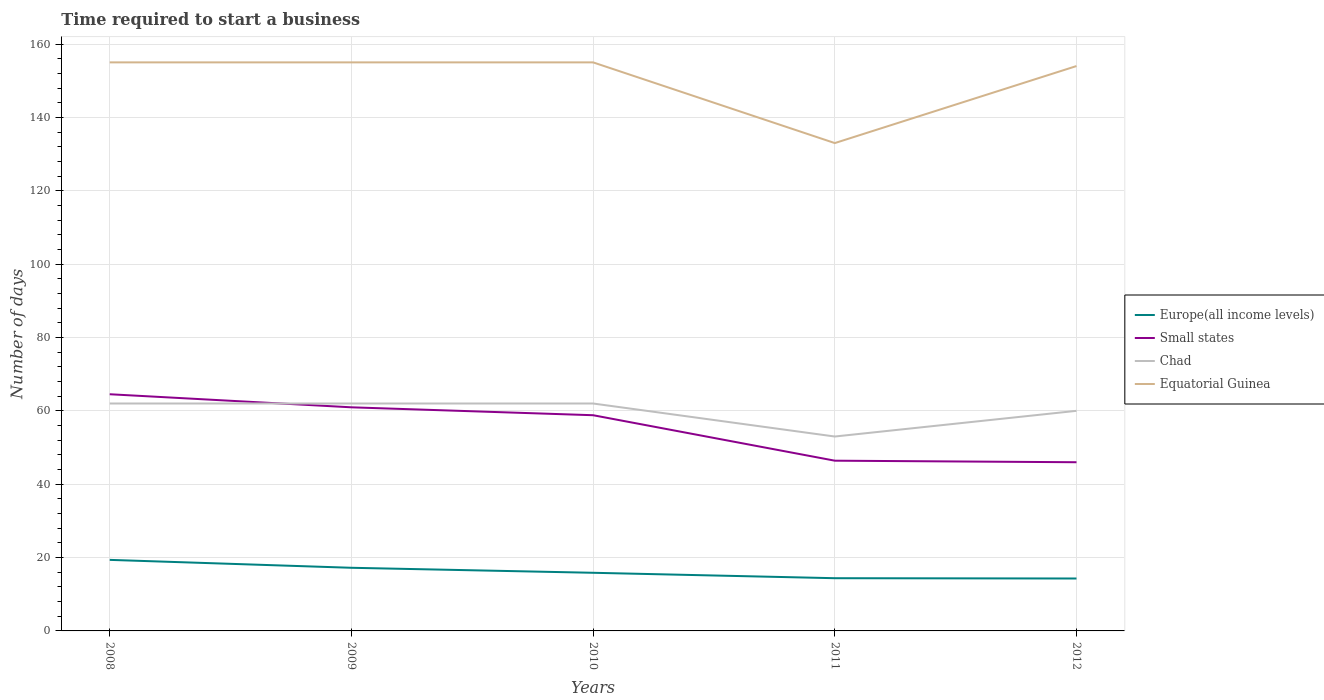Is the number of lines equal to the number of legend labels?
Provide a short and direct response. Yes. Across all years, what is the maximum number of days required to start a business in Chad?
Make the answer very short. 53. What is the total number of days required to start a business in Europe(all income levels) in the graph?
Your answer should be compact. 2.92. What is the difference between the highest and the second highest number of days required to start a business in Chad?
Your answer should be compact. 9. What is the difference between the highest and the lowest number of days required to start a business in Equatorial Guinea?
Provide a short and direct response. 4. Is the number of days required to start a business in Chad strictly greater than the number of days required to start a business in Europe(all income levels) over the years?
Your answer should be compact. No. What is the difference between two consecutive major ticks on the Y-axis?
Ensure brevity in your answer.  20. What is the title of the graph?
Provide a short and direct response. Time required to start a business. What is the label or title of the X-axis?
Give a very brief answer. Years. What is the label or title of the Y-axis?
Your answer should be compact. Number of days. What is the Number of days in Europe(all income levels) in 2008?
Ensure brevity in your answer.  19.37. What is the Number of days of Small states in 2008?
Provide a succinct answer. 64.53. What is the Number of days in Equatorial Guinea in 2008?
Offer a terse response. 155. What is the Number of days of Europe(all income levels) in 2009?
Your response must be concise. 17.21. What is the Number of days in Small states in 2009?
Your response must be concise. 60.96. What is the Number of days in Equatorial Guinea in 2009?
Provide a short and direct response. 155. What is the Number of days of Europe(all income levels) in 2010?
Offer a very short reply. 15.85. What is the Number of days in Small states in 2010?
Make the answer very short. 58.81. What is the Number of days of Equatorial Guinea in 2010?
Give a very brief answer. 155. What is the Number of days in Europe(all income levels) in 2011?
Give a very brief answer. 14.37. What is the Number of days of Small states in 2011?
Your answer should be very brief. 46.41. What is the Number of days in Chad in 2011?
Keep it short and to the point. 53. What is the Number of days in Equatorial Guinea in 2011?
Offer a very short reply. 133. What is the Number of days of Europe(all income levels) in 2012?
Your answer should be compact. 14.29. What is the Number of days of Small states in 2012?
Provide a succinct answer. 45.99. What is the Number of days of Equatorial Guinea in 2012?
Your answer should be compact. 154. Across all years, what is the maximum Number of days of Europe(all income levels)?
Your response must be concise. 19.37. Across all years, what is the maximum Number of days of Small states?
Keep it short and to the point. 64.53. Across all years, what is the maximum Number of days in Equatorial Guinea?
Provide a succinct answer. 155. Across all years, what is the minimum Number of days in Europe(all income levels)?
Ensure brevity in your answer.  14.29. Across all years, what is the minimum Number of days of Small states?
Offer a terse response. 45.99. Across all years, what is the minimum Number of days in Chad?
Make the answer very short. 53. Across all years, what is the minimum Number of days in Equatorial Guinea?
Offer a very short reply. 133. What is the total Number of days in Europe(all income levels) in the graph?
Give a very brief answer. 81.1. What is the total Number of days of Small states in the graph?
Ensure brevity in your answer.  276.69. What is the total Number of days in Chad in the graph?
Provide a short and direct response. 299. What is the total Number of days of Equatorial Guinea in the graph?
Your answer should be compact. 752. What is the difference between the Number of days of Europe(all income levels) in 2008 and that in 2009?
Your answer should be compact. 2.16. What is the difference between the Number of days in Small states in 2008 and that in 2009?
Ensure brevity in your answer.  3.56. What is the difference between the Number of days in Chad in 2008 and that in 2009?
Offer a terse response. 0. What is the difference between the Number of days in Europe(all income levels) in 2008 and that in 2010?
Your answer should be very brief. 3.52. What is the difference between the Number of days in Small states in 2008 and that in 2010?
Offer a very short reply. 5.72. What is the difference between the Number of days in Equatorial Guinea in 2008 and that in 2010?
Give a very brief answer. 0. What is the difference between the Number of days in Europe(all income levels) in 2008 and that in 2011?
Your answer should be compact. 5. What is the difference between the Number of days in Small states in 2008 and that in 2011?
Give a very brief answer. 18.11. What is the difference between the Number of days in Chad in 2008 and that in 2011?
Offer a terse response. 9. What is the difference between the Number of days of Europe(all income levels) in 2008 and that in 2012?
Keep it short and to the point. 5.08. What is the difference between the Number of days in Small states in 2008 and that in 2012?
Give a very brief answer. 18.54. What is the difference between the Number of days in Chad in 2008 and that in 2012?
Make the answer very short. 2. What is the difference between the Number of days in Europe(all income levels) in 2009 and that in 2010?
Give a very brief answer. 1.36. What is the difference between the Number of days of Small states in 2009 and that in 2010?
Make the answer very short. 2.15. What is the difference between the Number of days of Chad in 2009 and that in 2010?
Keep it short and to the point. 0. What is the difference between the Number of days in Equatorial Guinea in 2009 and that in 2010?
Provide a succinct answer. 0. What is the difference between the Number of days in Europe(all income levels) in 2009 and that in 2011?
Offer a terse response. 2.84. What is the difference between the Number of days in Small states in 2009 and that in 2011?
Make the answer very short. 14.55. What is the difference between the Number of days of Equatorial Guinea in 2009 and that in 2011?
Offer a very short reply. 22. What is the difference between the Number of days in Europe(all income levels) in 2009 and that in 2012?
Offer a very short reply. 2.92. What is the difference between the Number of days in Small states in 2009 and that in 2012?
Offer a terse response. 14.97. What is the difference between the Number of days of Chad in 2009 and that in 2012?
Provide a short and direct response. 2. What is the difference between the Number of days of Europe(all income levels) in 2010 and that in 2011?
Provide a succinct answer. 1.48. What is the difference between the Number of days of Small states in 2010 and that in 2011?
Your response must be concise. 12.4. What is the difference between the Number of days in Chad in 2010 and that in 2011?
Your answer should be very brief. 9. What is the difference between the Number of days in Equatorial Guinea in 2010 and that in 2011?
Provide a short and direct response. 22. What is the difference between the Number of days in Europe(all income levels) in 2010 and that in 2012?
Your answer should be very brief. 1.56. What is the difference between the Number of days of Small states in 2010 and that in 2012?
Your response must be concise. 12.82. What is the difference between the Number of days in Equatorial Guinea in 2010 and that in 2012?
Make the answer very short. 1. What is the difference between the Number of days in Europe(all income levels) in 2011 and that in 2012?
Provide a short and direct response. 0.08. What is the difference between the Number of days of Small states in 2011 and that in 2012?
Offer a terse response. 0.42. What is the difference between the Number of days in Europe(all income levels) in 2008 and the Number of days in Small states in 2009?
Your answer should be very brief. -41.59. What is the difference between the Number of days in Europe(all income levels) in 2008 and the Number of days in Chad in 2009?
Provide a succinct answer. -42.63. What is the difference between the Number of days of Europe(all income levels) in 2008 and the Number of days of Equatorial Guinea in 2009?
Give a very brief answer. -135.63. What is the difference between the Number of days in Small states in 2008 and the Number of days in Chad in 2009?
Your answer should be very brief. 2.53. What is the difference between the Number of days in Small states in 2008 and the Number of days in Equatorial Guinea in 2009?
Your answer should be very brief. -90.47. What is the difference between the Number of days in Chad in 2008 and the Number of days in Equatorial Guinea in 2009?
Offer a terse response. -93. What is the difference between the Number of days of Europe(all income levels) in 2008 and the Number of days of Small states in 2010?
Give a very brief answer. -39.44. What is the difference between the Number of days in Europe(all income levels) in 2008 and the Number of days in Chad in 2010?
Your answer should be very brief. -42.63. What is the difference between the Number of days of Europe(all income levels) in 2008 and the Number of days of Equatorial Guinea in 2010?
Your answer should be very brief. -135.63. What is the difference between the Number of days of Small states in 2008 and the Number of days of Chad in 2010?
Ensure brevity in your answer.  2.53. What is the difference between the Number of days of Small states in 2008 and the Number of days of Equatorial Guinea in 2010?
Your answer should be very brief. -90.47. What is the difference between the Number of days in Chad in 2008 and the Number of days in Equatorial Guinea in 2010?
Offer a very short reply. -93. What is the difference between the Number of days of Europe(all income levels) in 2008 and the Number of days of Small states in 2011?
Ensure brevity in your answer.  -27.04. What is the difference between the Number of days in Europe(all income levels) in 2008 and the Number of days in Chad in 2011?
Your answer should be compact. -33.63. What is the difference between the Number of days of Europe(all income levels) in 2008 and the Number of days of Equatorial Guinea in 2011?
Your answer should be very brief. -113.63. What is the difference between the Number of days of Small states in 2008 and the Number of days of Chad in 2011?
Ensure brevity in your answer.  11.53. What is the difference between the Number of days in Small states in 2008 and the Number of days in Equatorial Guinea in 2011?
Give a very brief answer. -68.47. What is the difference between the Number of days in Chad in 2008 and the Number of days in Equatorial Guinea in 2011?
Make the answer very short. -71. What is the difference between the Number of days in Europe(all income levels) in 2008 and the Number of days in Small states in 2012?
Make the answer very short. -26.62. What is the difference between the Number of days of Europe(all income levels) in 2008 and the Number of days of Chad in 2012?
Offer a terse response. -40.63. What is the difference between the Number of days of Europe(all income levels) in 2008 and the Number of days of Equatorial Guinea in 2012?
Make the answer very short. -134.63. What is the difference between the Number of days in Small states in 2008 and the Number of days in Chad in 2012?
Your response must be concise. 4.53. What is the difference between the Number of days in Small states in 2008 and the Number of days in Equatorial Guinea in 2012?
Provide a short and direct response. -89.47. What is the difference between the Number of days of Chad in 2008 and the Number of days of Equatorial Guinea in 2012?
Give a very brief answer. -92. What is the difference between the Number of days in Europe(all income levels) in 2009 and the Number of days in Small states in 2010?
Provide a succinct answer. -41.59. What is the difference between the Number of days in Europe(all income levels) in 2009 and the Number of days in Chad in 2010?
Keep it short and to the point. -44.79. What is the difference between the Number of days in Europe(all income levels) in 2009 and the Number of days in Equatorial Guinea in 2010?
Keep it short and to the point. -137.79. What is the difference between the Number of days of Small states in 2009 and the Number of days of Chad in 2010?
Give a very brief answer. -1.04. What is the difference between the Number of days of Small states in 2009 and the Number of days of Equatorial Guinea in 2010?
Provide a succinct answer. -94.04. What is the difference between the Number of days in Chad in 2009 and the Number of days in Equatorial Guinea in 2010?
Provide a succinct answer. -93. What is the difference between the Number of days of Europe(all income levels) in 2009 and the Number of days of Small states in 2011?
Provide a short and direct response. -29.2. What is the difference between the Number of days of Europe(all income levels) in 2009 and the Number of days of Chad in 2011?
Offer a very short reply. -35.79. What is the difference between the Number of days of Europe(all income levels) in 2009 and the Number of days of Equatorial Guinea in 2011?
Provide a succinct answer. -115.79. What is the difference between the Number of days in Small states in 2009 and the Number of days in Chad in 2011?
Ensure brevity in your answer.  7.96. What is the difference between the Number of days in Small states in 2009 and the Number of days in Equatorial Guinea in 2011?
Provide a succinct answer. -72.04. What is the difference between the Number of days in Chad in 2009 and the Number of days in Equatorial Guinea in 2011?
Your answer should be compact. -71. What is the difference between the Number of days in Europe(all income levels) in 2009 and the Number of days in Small states in 2012?
Your answer should be very brief. -28.77. What is the difference between the Number of days of Europe(all income levels) in 2009 and the Number of days of Chad in 2012?
Make the answer very short. -42.79. What is the difference between the Number of days in Europe(all income levels) in 2009 and the Number of days in Equatorial Guinea in 2012?
Offer a very short reply. -136.79. What is the difference between the Number of days in Small states in 2009 and the Number of days in Chad in 2012?
Keep it short and to the point. 0.96. What is the difference between the Number of days in Small states in 2009 and the Number of days in Equatorial Guinea in 2012?
Offer a very short reply. -93.04. What is the difference between the Number of days in Chad in 2009 and the Number of days in Equatorial Guinea in 2012?
Offer a terse response. -92. What is the difference between the Number of days of Europe(all income levels) in 2010 and the Number of days of Small states in 2011?
Ensure brevity in your answer.  -30.56. What is the difference between the Number of days in Europe(all income levels) in 2010 and the Number of days in Chad in 2011?
Ensure brevity in your answer.  -37.15. What is the difference between the Number of days in Europe(all income levels) in 2010 and the Number of days in Equatorial Guinea in 2011?
Your response must be concise. -117.15. What is the difference between the Number of days in Small states in 2010 and the Number of days in Chad in 2011?
Provide a succinct answer. 5.81. What is the difference between the Number of days of Small states in 2010 and the Number of days of Equatorial Guinea in 2011?
Provide a short and direct response. -74.19. What is the difference between the Number of days of Chad in 2010 and the Number of days of Equatorial Guinea in 2011?
Your response must be concise. -71. What is the difference between the Number of days in Europe(all income levels) in 2010 and the Number of days in Small states in 2012?
Offer a terse response. -30.14. What is the difference between the Number of days of Europe(all income levels) in 2010 and the Number of days of Chad in 2012?
Make the answer very short. -44.15. What is the difference between the Number of days in Europe(all income levels) in 2010 and the Number of days in Equatorial Guinea in 2012?
Ensure brevity in your answer.  -138.15. What is the difference between the Number of days of Small states in 2010 and the Number of days of Chad in 2012?
Give a very brief answer. -1.19. What is the difference between the Number of days of Small states in 2010 and the Number of days of Equatorial Guinea in 2012?
Your answer should be very brief. -95.19. What is the difference between the Number of days in Chad in 2010 and the Number of days in Equatorial Guinea in 2012?
Provide a succinct answer. -92. What is the difference between the Number of days in Europe(all income levels) in 2011 and the Number of days in Small states in 2012?
Ensure brevity in your answer.  -31.62. What is the difference between the Number of days of Europe(all income levels) in 2011 and the Number of days of Chad in 2012?
Provide a short and direct response. -45.63. What is the difference between the Number of days of Europe(all income levels) in 2011 and the Number of days of Equatorial Guinea in 2012?
Ensure brevity in your answer.  -139.63. What is the difference between the Number of days of Small states in 2011 and the Number of days of Chad in 2012?
Provide a short and direct response. -13.59. What is the difference between the Number of days in Small states in 2011 and the Number of days in Equatorial Guinea in 2012?
Provide a succinct answer. -107.59. What is the difference between the Number of days in Chad in 2011 and the Number of days in Equatorial Guinea in 2012?
Provide a short and direct response. -101. What is the average Number of days in Europe(all income levels) per year?
Ensure brevity in your answer.  16.22. What is the average Number of days in Small states per year?
Keep it short and to the point. 55.34. What is the average Number of days in Chad per year?
Your answer should be very brief. 59.8. What is the average Number of days in Equatorial Guinea per year?
Your response must be concise. 150.4. In the year 2008, what is the difference between the Number of days of Europe(all income levels) and Number of days of Small states?
Provide a succinct answer. -45.16. In the year 2008, what is the difference between the Number of days of Europe(all income levels) and Number of days of Chad?
Provide a succinct answer. -42.63. In the year 2008, what is the difference between the Number of days of Europe(all income levels) and Number of days of Equatorial Guinea?
Ensure brevity in your answer.  -135.63. In the year 2008, what is the difference between the Number of days of Small states and Number of days of Chad?
Your response must be concise. 2.53. In the year 2008, what is the difference between the Number of days of Small states and Number of days of Equatorial Guinea?
Your answer should be compact. -90.47. In the year 2008, what is the difference between the Number of days of Chad and Number of days of Equatorial Guinea?
Provide a short and direct response. -93. In the year 2009, what is the difference between the Number of days of Europe(all income levels) and Number of days of Small states?
Your response must be concise. -43.75. In the year 2009, what is the difference between the Number of days in Europe(all income levels) and Number of days in Chad?
Ensure brevity in your answer.  -44.79. In the year 2009, what is the difference between the Number of days of Europe(all income levels) and Number of days of Equatorial Guinea?
Keep it short and to the point. -137.79. In the year 2009, what is the difference between the Number of days in Small states and Number of days in Chad?
Your answer should be compact. -1.04. In the year 2009, what is the difference between the Number of days in Small states and Number of days in Equatorial Guinea?
Provide a succinct answer. -94.04. In the year 2009, what is the difference between the Number of days in Chad and Number of days in Equatorial Guinea?
Your answer should be very brief. -93. In the year 2010, what is the difference between the Number of days in Europe(all income levels) and Number of days in Small states?
Offer a very short reply. -42.96. In the year 2010, what is the difference between the Number of days in Europe(all income levels) and Number of days in Chad?
Provide a short and direct response. -46.15. In the year 2010, what is the difference between the Number of days of Europe(all income levels) and Number of days of Equatorial Guinea?
Offer a terse response. -139.15. In the year 2010, what is the difference between the Number of days of Small states and Number of days of Chad?
Make the answer very short. -3.19. In the year 2010, what is the difference between the Number of days in Small states and Number of days in Equatorial Guinea?
Your response must be concise. -96.19. In the year 2010, what is the difference between the Number of days in Chad and Number of days in Equatorial Guinea?
Provide a succinct answer. -93. In the year 2011, what is the difference between the Number of days in Europe(all income levels) and Number of days in Small states?
Make the answer very short. -32.04. In the year 2011, what is the difference between the Number of days of Europe(all income levels) and Number of days of Chad?
Keep it short and to the point. -38.63. In the year 2011, what is the difference between the Number of days in Europe(all income levels) and Number of days in Equatorial Guinea?
Your response must be concise. -118.63. In the year 2011, what is the difference between the Number of days of Small states and Number of days of Chad?
Ensure brevity in your answer.  -6.59. In the year 2011, what is the difference between the Number of days of Small states and Number of days of Equatorial Guinea?
Keep it short and to the point. -86.59. In the year 2011, what is the difference between the Number of days of Chad and Number of days of Equatorial Guinea?
Keep it short and to the point. -80. In the year 2012, what is the difference between the Number of days of Europe(all income levels) and Number of days of Small states?
Provide a succinct answer. -31.7. In the year 2012, what is the difference between the Number of days in Europe(all income levels) and Number of days in Chad?
Offer a very short reply. -45.71. In the year 2012, what is the difference between the Number of days in Europe(all income levels) and Number of days in Equatorial Guinea?
Your answer should be compact. -139.71. In the year 2012, what is the difference between the Number of days of Small states and Number of days of Chad?
Your answer should be compact. -14.01. In the year 2012, what is the difference between the Number of days of Small states and Number of days of Equatorial Guinea?
Keep it short and to the point. -108.01. In the year 2012, what is the difference between the Number of days of Chad and Number of days of Equatorial Guinea?
Ensure brevity in your answer.  -94. What is the ratio of the Number of days in Europe(all income levels) in 2008 to that in 2009?
Provide a short and direct response. 1.13. What is the ratio of the Number of days in Small states in 2008 to that in 2009?
Your answer should be very brief. 1.06. What is the ratio of the Number of days in Chad in 2008 to that in 2009?
Make the answer very short. 1. What is the ratio of the Number of days of Equatorial Guinea in 2008 to that in 2009?
Provide a succinct answer. 1. What is the ratio of the Number of days in Europe(all income levels) in 2008 to that in 2010?
Ensure brevity in your answer.  1.22. What is the ratio of the Number of days in Small states in 2008 to that in 2010?
Your answer should be very brief. 1.1. What is the ratio of the Number of days of Europe(all income levels) in 2008 to that in 2011?
Provide a succinct answer. 1.35. What is the ratio of the Number of days of Small states in 2008 to that in 2011?
Provide a succinct answer. 1.39. What is the ratio of the Number of days in Chad in 2008 to that in 2011?
Your answer should be compact. 1.17. What is the ratio of the Number of days in Equatorial Guinea in 2008 to that in 2011?
Your answer should be compact. 1.17. What is the ratio of the Number of days of Europe(all income levels) in 2008 to that in 2012?
Provide a succinct answer. 1.36. What is the ratio of the Number of days in Small states in 2008 to that in 2012?
Give a very brief answer. 1.4. What is the ratio of the Number of days in Europe(all income levels) in 2009 to that in 2010?
Your answer should be very brief. 1.09. What is the ratio of the Number of days of Small states in 2009 to that in 2010?
Make the answer very short. 1.04. What is the ratio of the Number of days of Europe(all income levels) in 2009 to that in 2011?
Your answer should be compact. 1.2. What is the ratio of the Number of days in Small states in 2009 to that in 2011?
Give a very brief answer. 1.31. What is the ratio of the Number of days in Chad in 2009 to that in 2011?
Ensure brevity in your answer.  1.17. What is the ratio of the Number of days of Equatorial Guinea in 2009 to that in 2011?
Provide a succinct answer. 1.17. What is the ratio of the Number of days of Europe(all income levels) in 2009 to that in 2012?
Offer a very short reply. 1.2. What is the ratio of the Number of days of Small states in 2009 to that in 2012?
Provide a short and direct response. 1.33. What is the ratio of the Number of days of Equatorial Guinea in 2009 to that in 2012?
Make the answer very short. 1.01. What is the ratio of the Number of days of Europe(all income levels) in 2010 to that in 2011?
Keep it short and to the point. 1.1. What is the ratio of the Number of days of Small states in 2010 to that in 2011?
Provide a short and direct response. 1.27. What is the ratio of the Number of days of Chad in 2010 to that in 2011?
Provide a succinct answer. 1.17. What is the ratio of the Number of days of Equatorial Guinea in 2010 to that in 2011?
Provide a succinct answer. 1.17. What is the ratio of the Number of days of Europe(all income levels) in 2010 to that in 2012?
Provide a succinct answer. 1.11. What is the ratio of the Number of days in Small states in 2010 to that in 2012?
Make the answer very short. 1.28. What is the ratio of the Number of days in Chad in 2010 to that in 2012?
Ensure brevity in your answer.  1.03. What is the ratio of the Number of days of Equatorial Guinea in 2010 to that in 2012?
Keep it short and to the point. 1.01. What is the ratio of the Number of days in Europe(all income levels) in 2011 to that in 2012?
Your response must be concise. 1.01. What is the ratio of the Number of days of Small states in 2011 to that in 2012?
Your response must be concise. 1.01. What is the ratio of the Number of days of Chad in 2011 to that in 2012?
Offer a very short reply. 0.88. What is the ratio of the Number of days of Equatorial Guinea in 2011 to that in 2012?
Ensure brevity in your answer.  0.86. What is the difference between the highest and the second highest Number of days of Europe(all income levels)?
Give a very brief answer. 2.16. What is the difference between the highest and the second highest Number of days of Small states?
Ensure brevity in your answer.  3.56. What is the difference between the highest and the lowest Number of days of Europe(all income levels)?
Give a very brief answer. 5.08. What is the difference between the highest and the lowest Number of days in Small states?
Your response must be concise. 18.54. What is the difference between the highest and the lowest Number of days of Chad?
Your answer should be very brief. 9. 